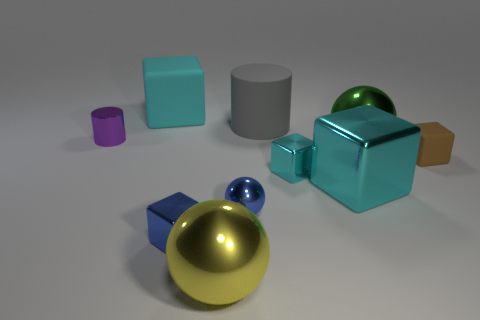Subtract all blue cubes. How many cubes are left? 4 Subtract all green cylinders. How many cyan cubes are left? 3 Subtract 5 blocks. How many blocks are left? 0 Subtract all spheres. How many objects are left? 7 Subtract all gray cylinders. How many cylinders are left? 1 Add 7 large metal cubes. How many large metal cubes exist? 8 Subtract 0 brown cylinders. How many objects are left? 10 Subtract all purple cylinders. Subtract all blue spheres. How many cylinders are left? 1 Subtract all gray cylinders. Subtract all big blocks. How many objects are left? 7 Add 2 brown matte cubes. How many brown matte cubes are left? 3 